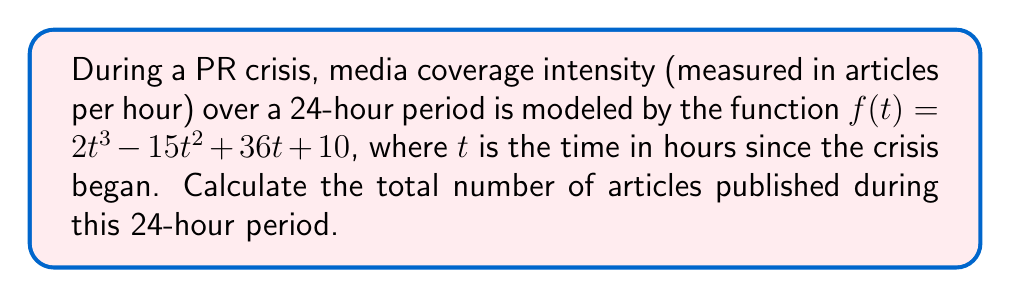Could you help me with this problem? To solve this problem, we need to find the area under the curve of $f(t)$ from $t=0$ to $t=24$. This can be done using a definite integral.

1) The definite integral we need to calculate is:

   $$\int_0^{24} (2t^3 - 15t^2 + 36t + 10) dt$$

2) Let's integrate each term:
   
   $$\int 2t^3 dt = \frac{1}{2}t^4$$
   $$\int -15t^2 dt = -5t^3$$
   $$\int 36t dt = 18t^2$$
   $$\int 10 dt = 10t$$

3) Now, we can write the antiderivative:

   $$F(t) = \frac{1}{2}t^4 - 5t^3 + 18t^2 + 10t + C$$

4) Apply the Fundamental Theorem of Calculus:

   $$\int_0^{24} f(t) dt = F(24) - F(0)$$

5) Calculate $F(24)$:
   
   $$F(24) = \frac{1}{2}(24^4) - 5(24^3) + 18(24^2) + 10(24) = 165,888$$

6) Calculate $F(0)$:
   
   $$F(0) = 0$$

7) Subtract:

   $$F(24) - F(0) = 165,888 - 0 = 165,888$$

Therefore, the total number of articles published during the 24-hour period is 165,888.
Answer: 165,888 articles 